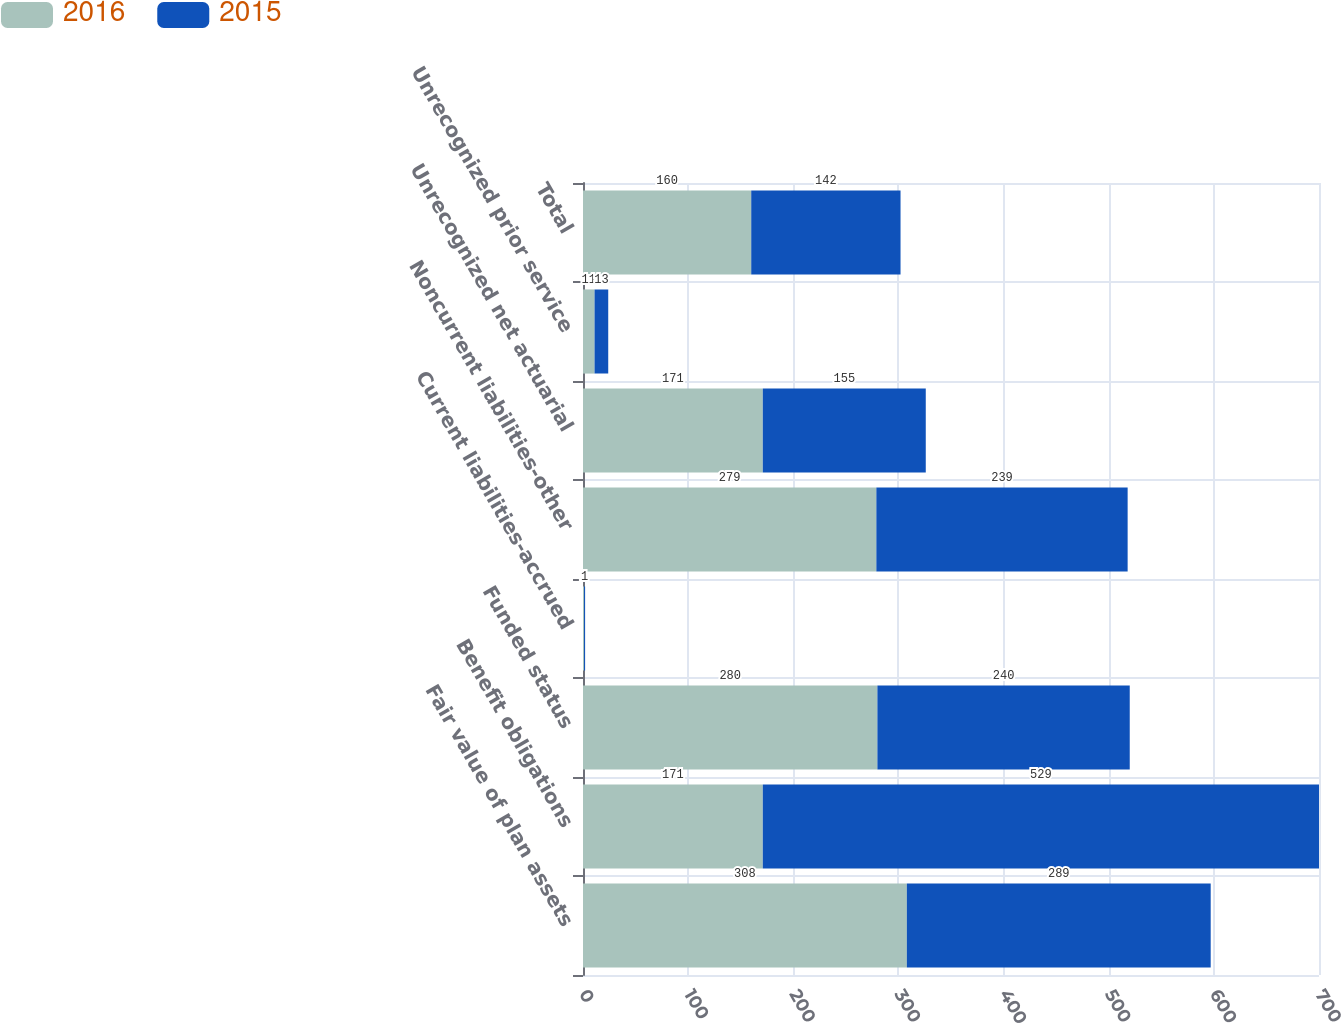Convert chart to OTSL. <chart><loc_0><loc_0><loc_500><loc_500><stacked_bar_chart><ecel><fcel>Fair value of plan assets<fcel>Benefit obligations<fcel>Funded status<fcel>Current liabilities-accrued<fcel>Noncurrent liabilities-other<fcel>Unrecognized net actuarial<fcel>Unrecognized prior service<fcel>Total<nl><fcel>2016<fcel>308<fcel>171<fcel>280<fcel>1<fcel>279<fcel>171<fcel>11<fcel>160<nl><fcel>2015<fcel>289<fcel>529<fcel>240<fcel>1<fcel>239<fcel>155<fcel>13<fcel>142<nl></chart> 